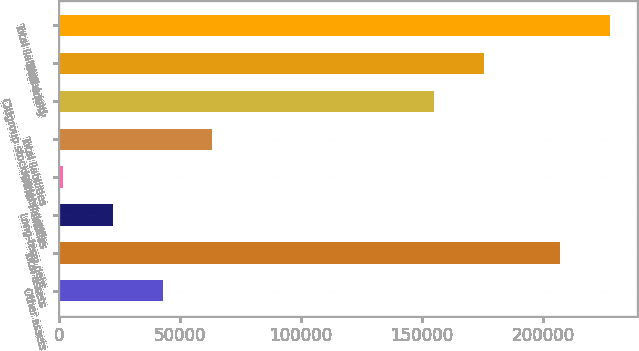Convert chart to OTSL. <chart><loc_0><loc_0><loc_500><loc_500><bar_chart><fcel>Other assets<fcel>Total assets<fcel>Long-term debt<fcel>Other liabilities<fcel>Total liabilities<fcel>Citigroup stockholders' equity<fcel>Total equity<fcel>Total liabilities and<nl><fcel>42898.4<fcel>206864<fcel>22402.7<fcel>1907<fcel>63394.1<fcel>154828<fcel>175324<fcel>227360<nl></chart> 